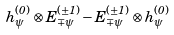Convert formula to latex. <formula><loc_0><loc_0><loc_500><loc_500>h _ { \psi } ^ { ( 0 ) } \otimes E _ { \mp \psi } ^ { ( \pm 1 ) } - E _ { \mp \psi } ^ { ( \pm 1 ) } \otimes h _ { \psi } ^ { ( 0 ) }</formula> 